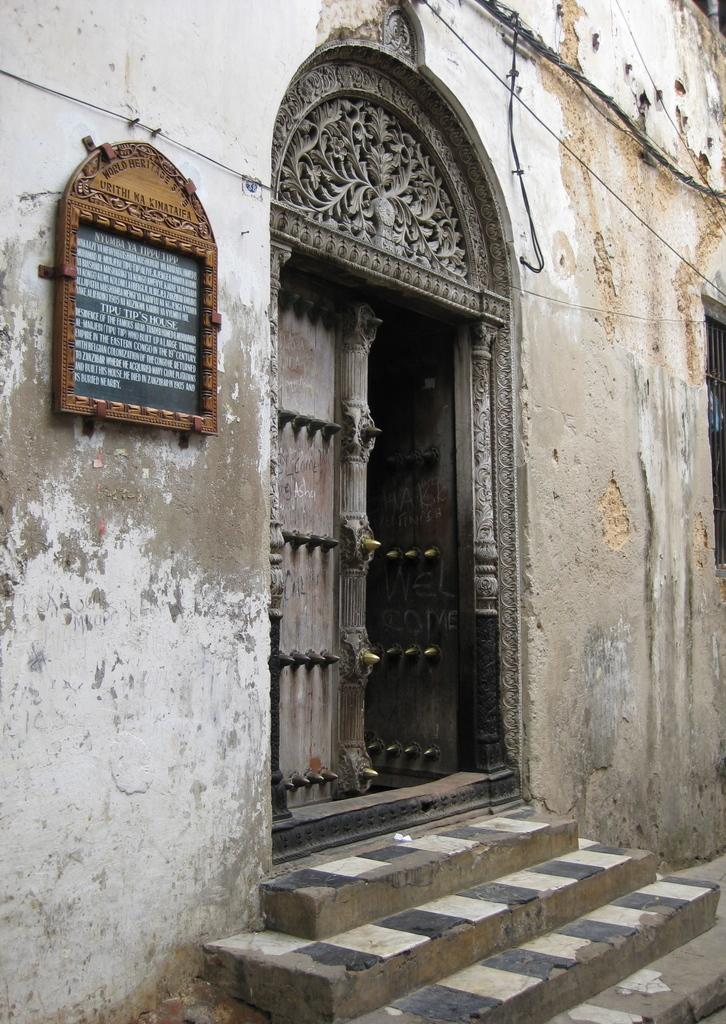What type of structure is present in the image? There is a building in the image. What features of the building can be identified? The building has a door and stairs. Is there any additional information displayed on the building? Yes, there is a board with text attached to the building. What shape is the tramp in the image? There is no tramp present in the image. What type of division can be seen between the building and the adjacent structure? The image does not show any adjacent structure or division between structures. 